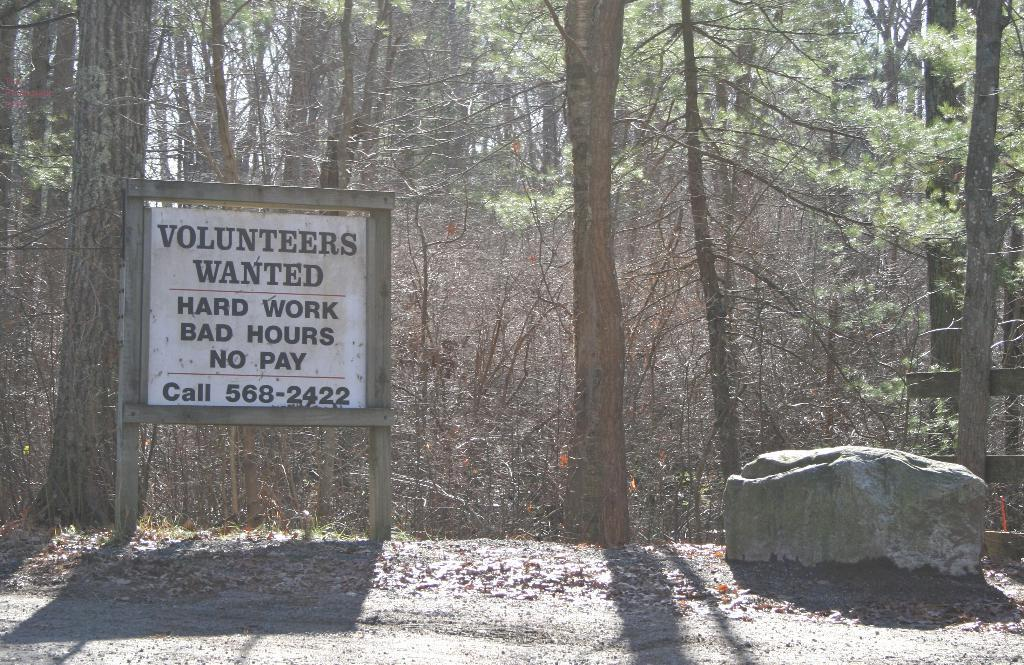What is the main subject in the center of the image? There is a board with text in the center of the image. What can be seen in the background of the image? There are trees in the background of the image. What object is located on the right side of the image? There is a stone on the right side of the image. How many hands are visible in the image? There are no hands visible in the image. What type of bed is present in the image? There is no bed present in the image. 